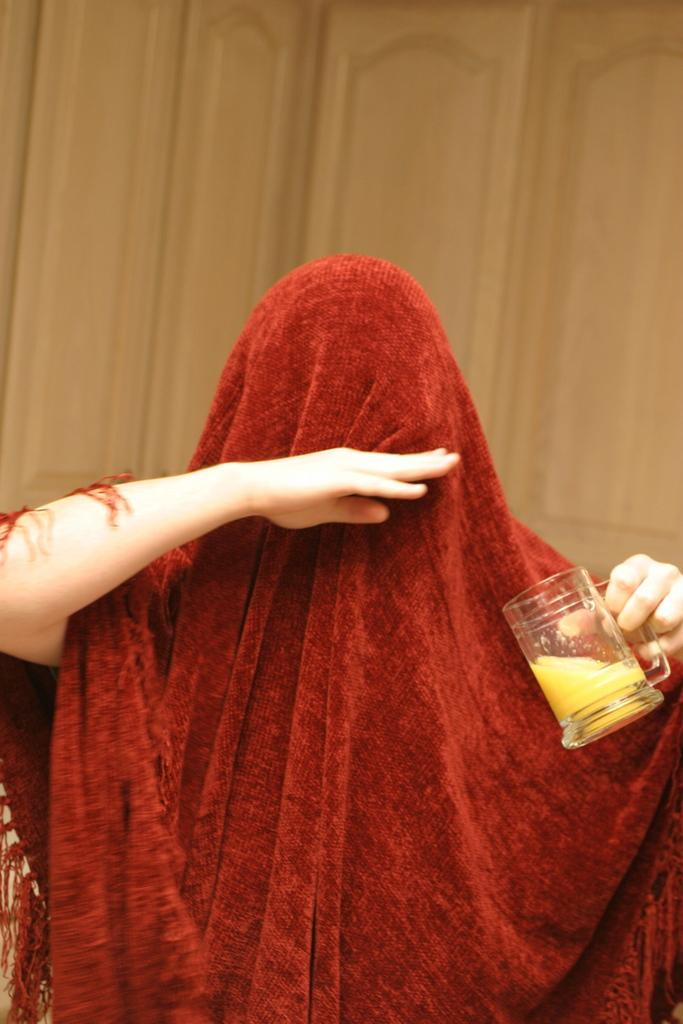What is the main subject of the image? There is a person in the image. What is the person doing in the image? The person is standing. What is the person wearing in the image? The person is wearing a scarf. What object is the person holding in the image? The person is holding a glass. What is the tendency of the leaf in the image? There is no leaf present in the image, so it is not possible to determine its tendency. 